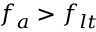<formula> <loc_0><loc_0><loc_500><loc_500>f _ { a } > f _ { l t }</formula> 